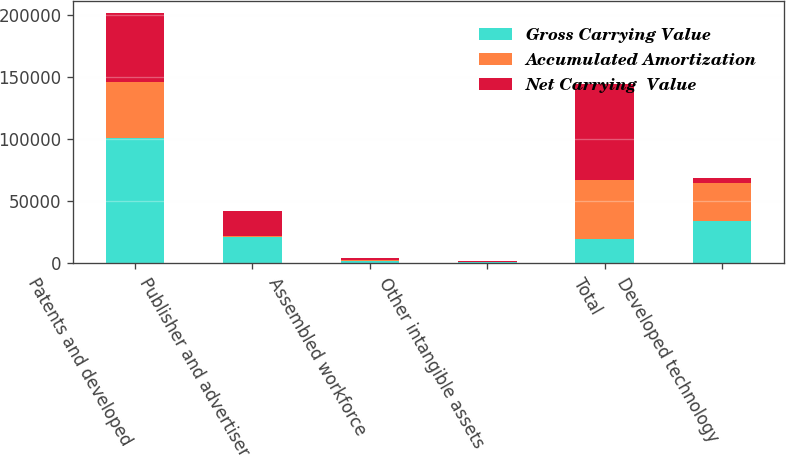<chart> <loc_0><loc_0><loc_500><loc_500><stacked_bar_chart><ecel><fcel>Patents and developed<fcel>Publisher and advertiser<fcel>Assembled workforce<fcel>Other intangible assets<fcel>Total<fcel>Developed technology<nl><fcel>Gross Carrying Value<fcel>100553<fcel>21100<fcel>1960<fcel>1100<fcel>19852<fcel>34309<nl><fcel>Accumulated Amortization<fcel>45440<fcel>1248<fcel>300<fcel>98<fcel>47086<fcel>30556<nl><fcel>Net Carrying  Value<fcel>55113<fcel>19852<fcel>1660<fcel>1002<fcel>77627<fcel>3753<nl></chart> 